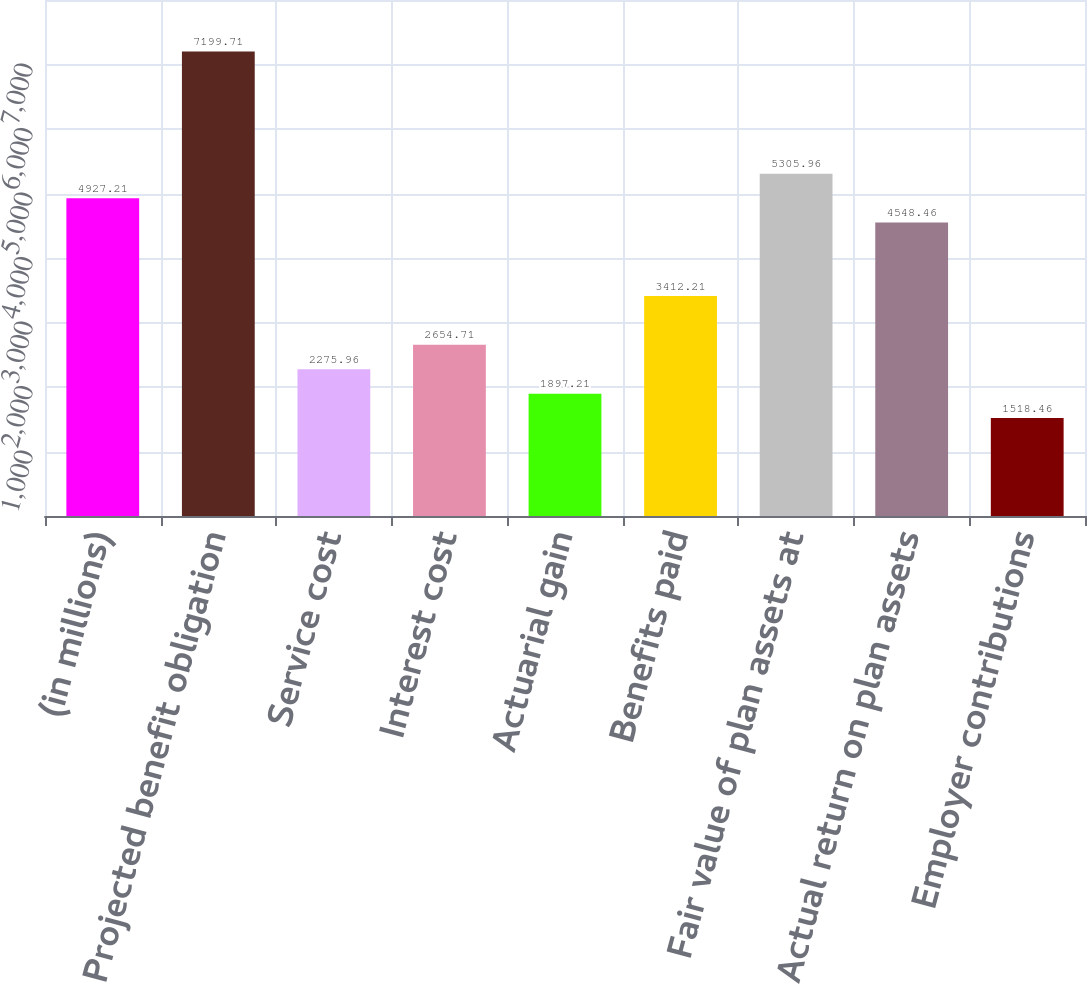Convert chart. <chart><loc_0><loc_0><loc_500><loc_500><bar_chart><fcel>(in millions)<fcel>Projected benefit obligation<fcel>Service cost<fcel>Interest cost<fcel>Actuarial gain<fcel>Benefits paid<fcel>Fair value of plan assets at<fcel>Actual return on plan assets<fcel>Employer contributions<nl><fcel>4927.21<fcel>7199.71<fcel>2275.96<fcel>2654.71<fcel>1897.21<fcel>3412.21<fcel>5305.96<fcel>4548.46<fcel>1518.46<nl></chart> 